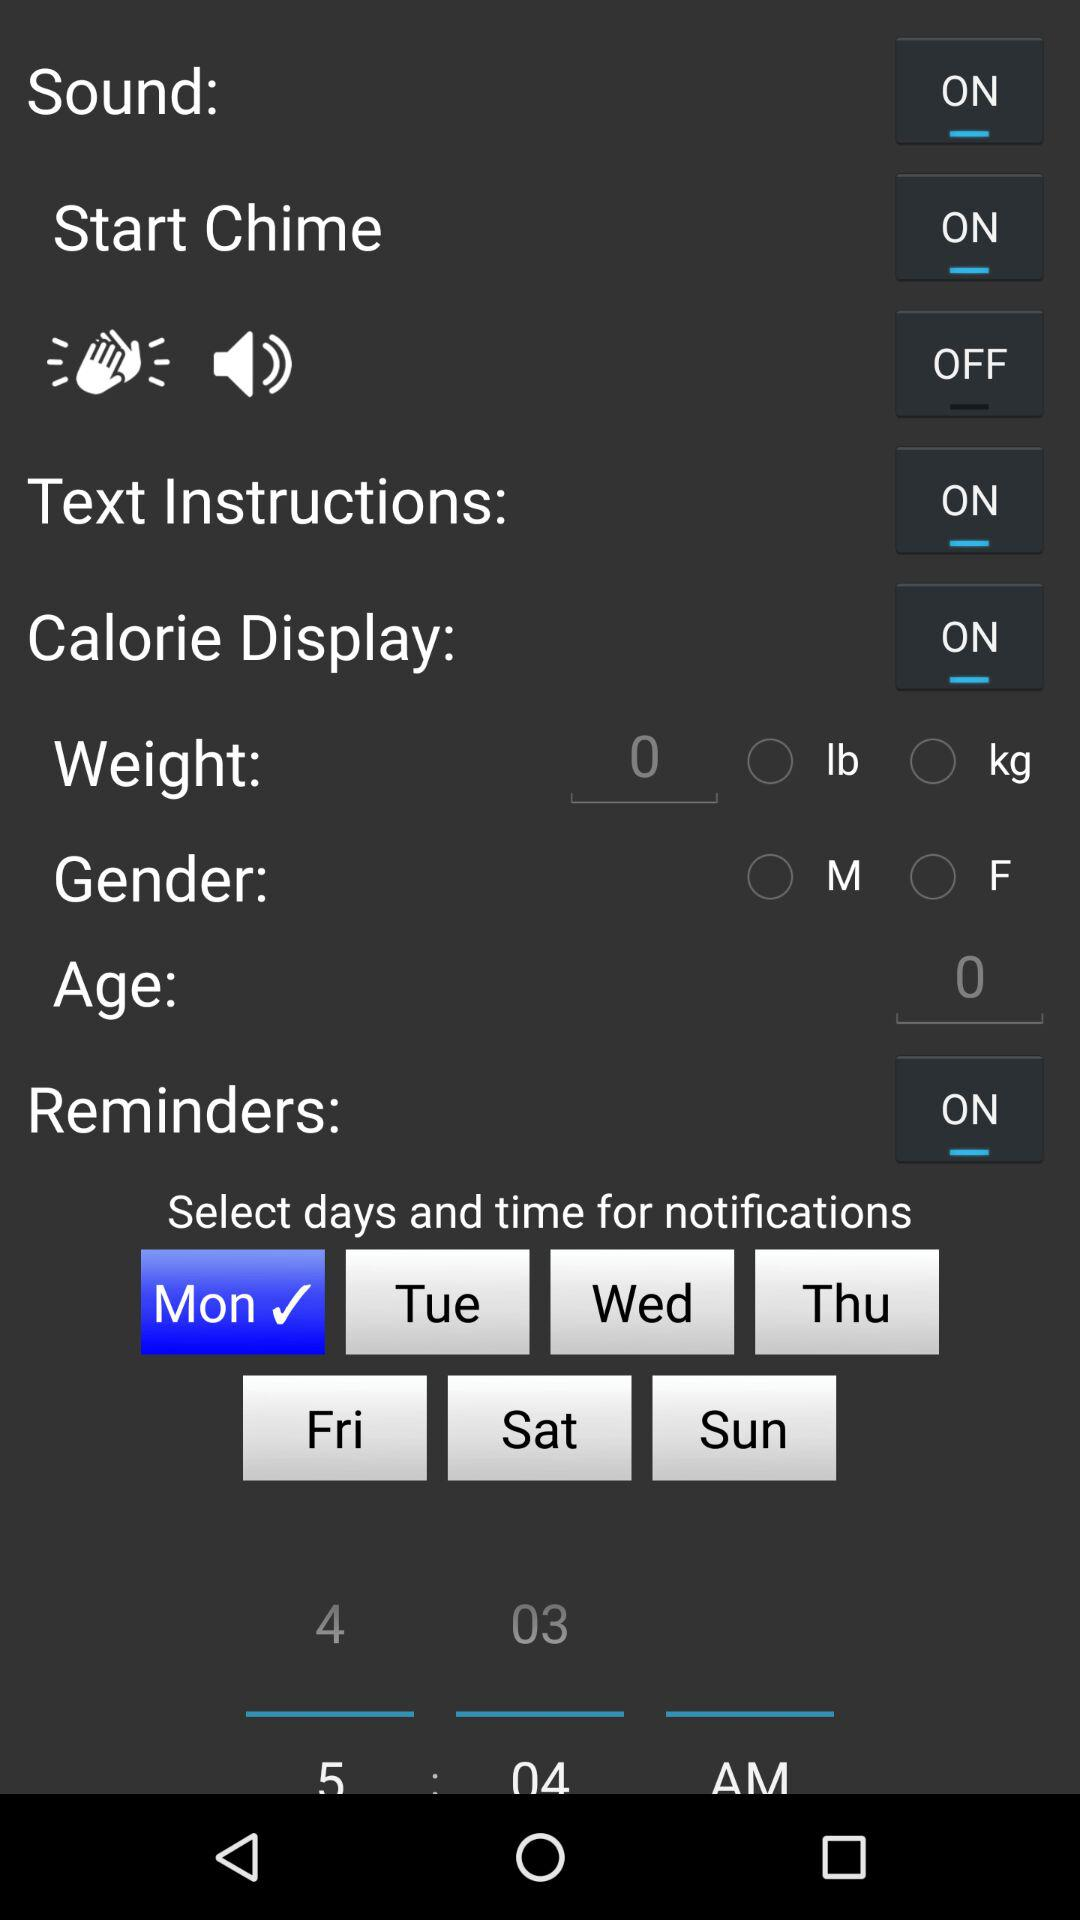Which day is selected for notifications? For notifications, Monday is selected. 